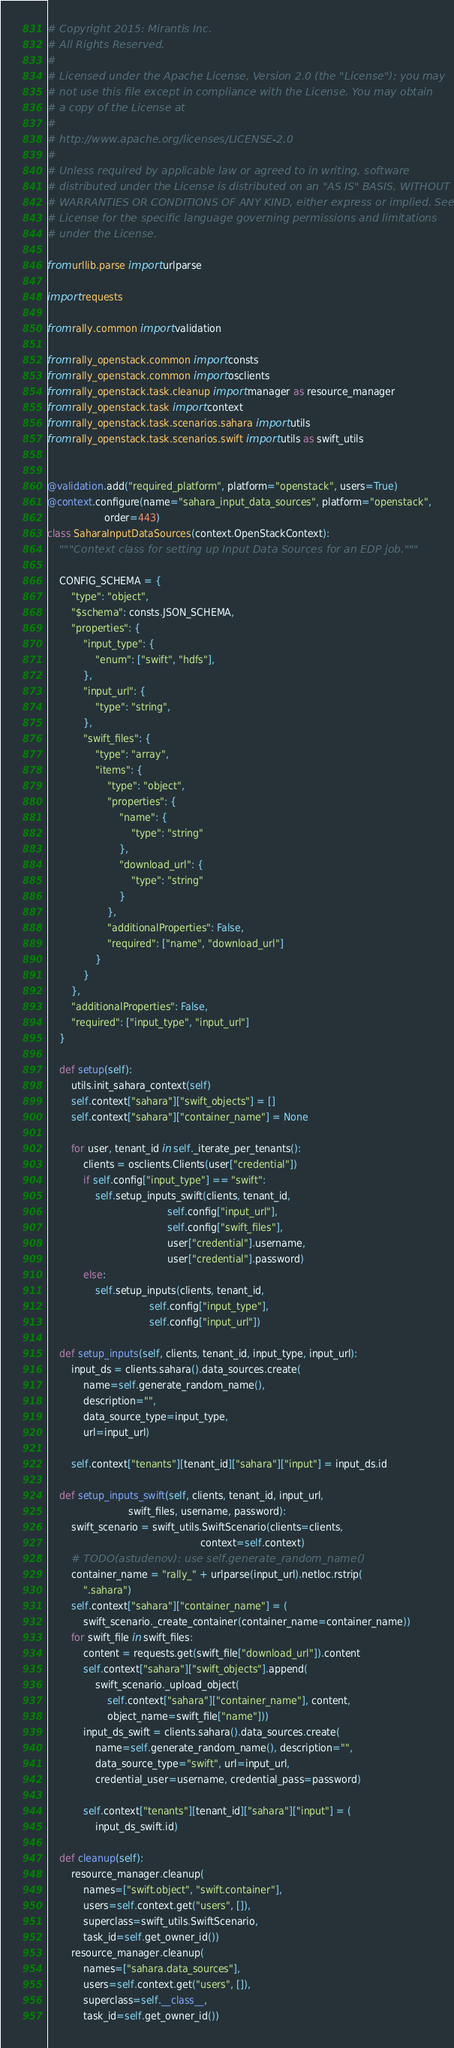<code> <loc_0><loc_0><loc_500><loc_500><_Python_># Copyright 2015: Mirantis Inc.
# All Rights Reserved.
#
# Licensed under the Apache License, Version 2.0 (the "License"); you may
# not use this file except in compliance with the License. You may obtain
# a copy of the License at
#
# http://www.apache.org/licenses/LICENSE-2.0
#
# Unless required by applicable law or agreed to in writing, software
# distributed under the License is distributed on an "AS IS" BASIS, WITHOUT
# WARRANTIES OR CONDITIONS OF ANY KIND, either express or implied. See the
# License for the specific language governing permissions and limitations
# under the License.

from urllib.parse import urlparse

import requests

from rally.common import validation

from rally_openstack.common import consts
from rally_openstack.common import osclients
from rally_openstack.task.cleanup import manager as resource_manager
from rally_openstack.task import context
from rally_openstack.task.scenarios.sahara import utils
from rally_openstack.task.scenarios.swift import utils as swift_utils


@validation.add("required_platform", platform="openstack", users=True)
@context.configure(name="sahara_input_data_sources", platform="openstack",
                   order=443)
class SaharaInputDataSources(context.OpenStackContext):
    """Context class for setting up Input Data Sources for an EDP job."""

    CONFIG_SCHEMA = {
        "type": "object",
        "$schema": consts.JSON_SCHEMA,
        "properties": {
            "input_type": {
                "enum": ["swift", "hdfs"],
            },
            "input_url": {
                "type": "string",
            },
            "swift_files": {
                "type": "array",
                "items": {
                    "type": "object",
                    "properties": {
                        "name": {
                            "type": "string"
                        },
                        "download_url": {
                            "type": "string"
                        }
                    },
                    "additionalProperties": False,
                    "required": ["name", "download_url"]
                }
            }
        },
        "additionalProperties": False,
        "required": ["input_type", "input_url"]
    }

    def setup(self):
        utils.init_sahara_context(self)
        self.context["sahara"]["swift_objects"] = []
        self.context["sahara"]["container_name"] = None

        for user, tenant_id in self._iterate_per_tenants():
            clients = osclients.Clients(user["credential"])
            if self.config["input_type"] == "swift":
                self.setup_inputs_swift(clients, tenant_id,
                                        self.config["input_url"],
                                        self.config["swift_files"],
                                        user["credential"].username,
                                        user["credential"].password)
            else:
                self.setup_inputs(clients, tenant_id,
                                  self.config["input_type"],
                                  self.config["input_url"])

    def setup_inputs(self, clients, tenant_id, input_type, input_url):
        input_ds = clients.sahara().data_sources.create(
            name=self.generate_random_name(),
            description="",
            data_source_type=input_type,
            url=input_url)

        self.context["tenants"][tenant_id]["sahara"]["input"] = input_ds.id

    def setup_inputs_swift(self, clients, tenant_id, input_url,
                           swift_files, username, password):
        swift_scenario = swift_utils.SwiftScenario(clients=clients,
                                                   context=self.context)
        # TODO(astudenov): use self.generate_random_name()
        container_name = "rally_" + urlparse(input_url).netloc.rstrip(
            ".sahara")
        self.context["sahara"]["container_name"] = (
            swift_scenario._create_container(container_name=container_name))
        for swift_file in swift_files:
            content = requests.get(swift_file["download_url"]).content
            self.context["sahara"]["swift_objects"].append(
                swift_scenario._upload_object(
                    self.context["sahara"]["container_name"], content,
                    object_name=swift_file["name"]))
            input_ds_swift = clients.sahara().data_sources.create(
                name=self.generate_random_name(), description="",
                data_source_type="swift", url=input_url,
                credential_user=username, credential_pass=password)

            self.context["tenants"][tenant_id]["sahara"]["input"] = (
                input_ds_swift.id)

    def cleanup(self):
        resource_manager.cleanup(
            names=["swift.object", "swift.container"],
            users=self.context.get("users", []),
            superclass=swift_utils.SwiftScenario,
            task_id=self.get_owner_id())
        resource_manager.cleanup(
            names=["sahara.data_sources"],
            users=self.context.get("users", []),
            superclass=self.__class__,
            task_id=self.get_owner_id())
</code> 